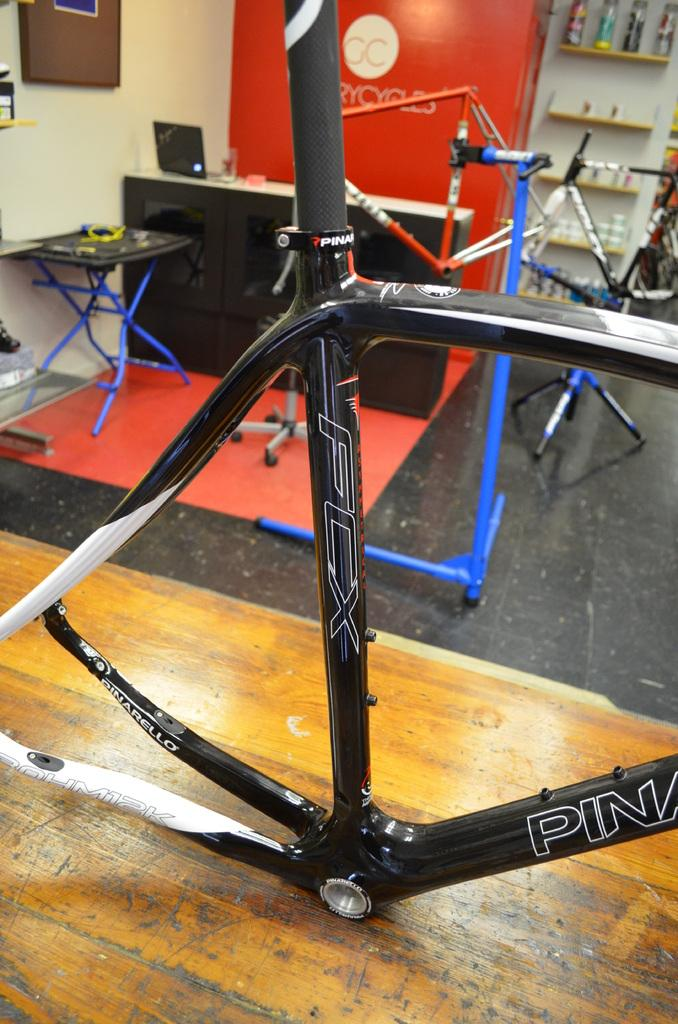What type of objects can be seen in the room? There are instruments in the room. Can you describe the instruments in the room? Unfortunately, the provided facts do not specify the types of instruments present in the room. How many instruments can be seen in the room? The number of instruments in the room is not mentioned in the provided facts. What type of insect can be seen crawling on the tiger during the thunderstorm in the image? There is no insect, tiger, or thunderstorm present in the image. The image only features instruments in a room. 